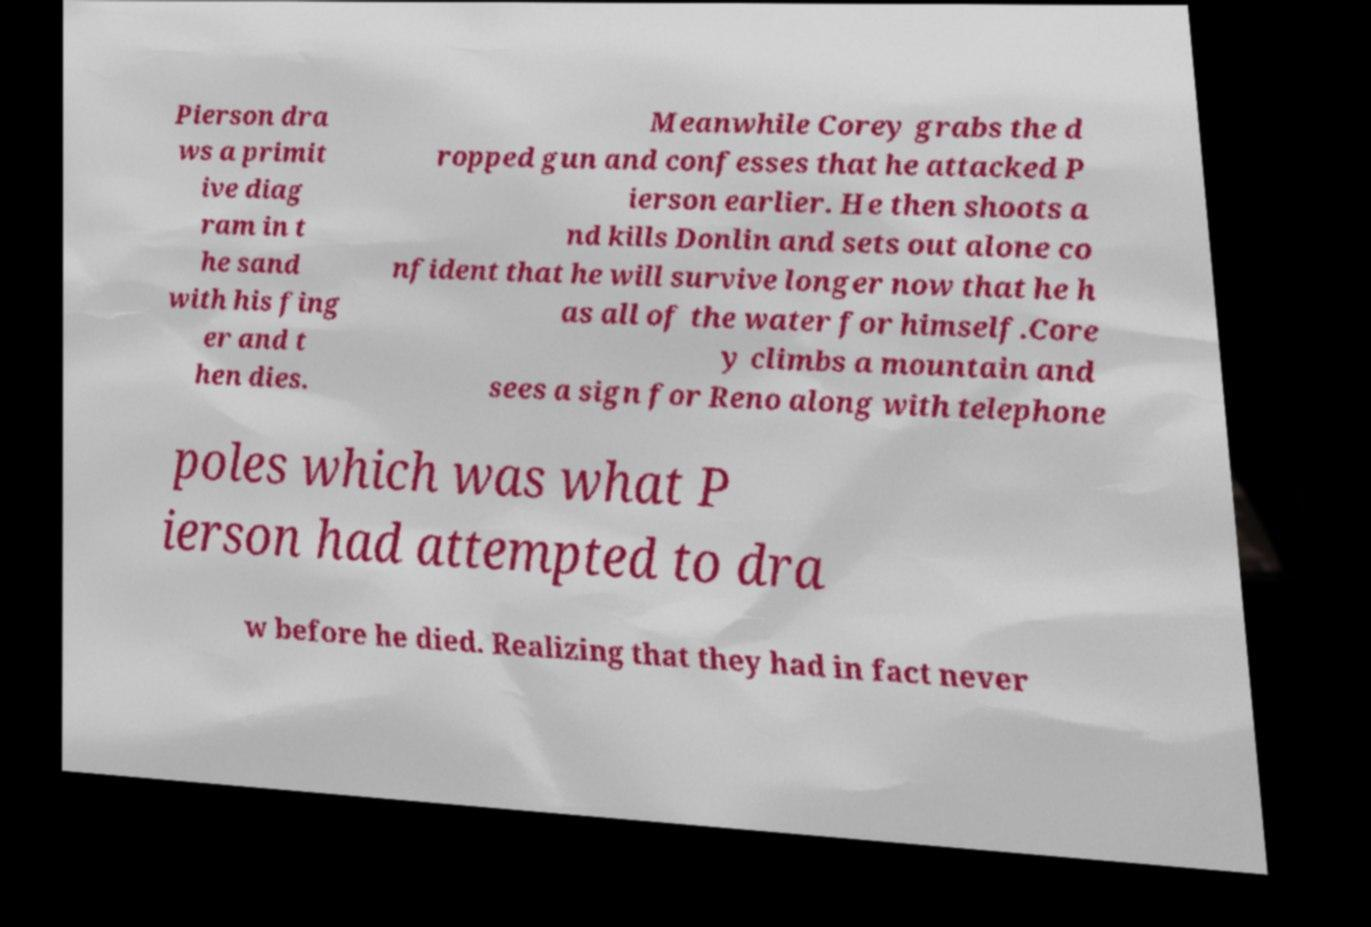Can you accurately transcribe the text from the provided image for me? Pierson dra ws a primit ive diag ram in t he sand with his fing er and t hen dies. Meanwhile Corey grabs the d ropped gun and confesses that he attacked P ierson earlier. He then shoots a nd kills Donlin and sets out alone co nfident that he will survive longer now that he h as all of the water for himself.Core y climbs a mountain and sees a sign for Reno along with telephone poles which was what P ierson had attempted to dra w before he died. Realizing that they had in fact never 